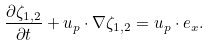<formula> <loc_0><loc_0><loc_500><loc_500>\frac { \partial \zeta _ { 1 , 2 } } { \partial t } + { u } _ { p } \cdot \nabla \zeta _ { 1 , 2 } = { u } _ { p } \cdot { e } _ { x } .</formula> 